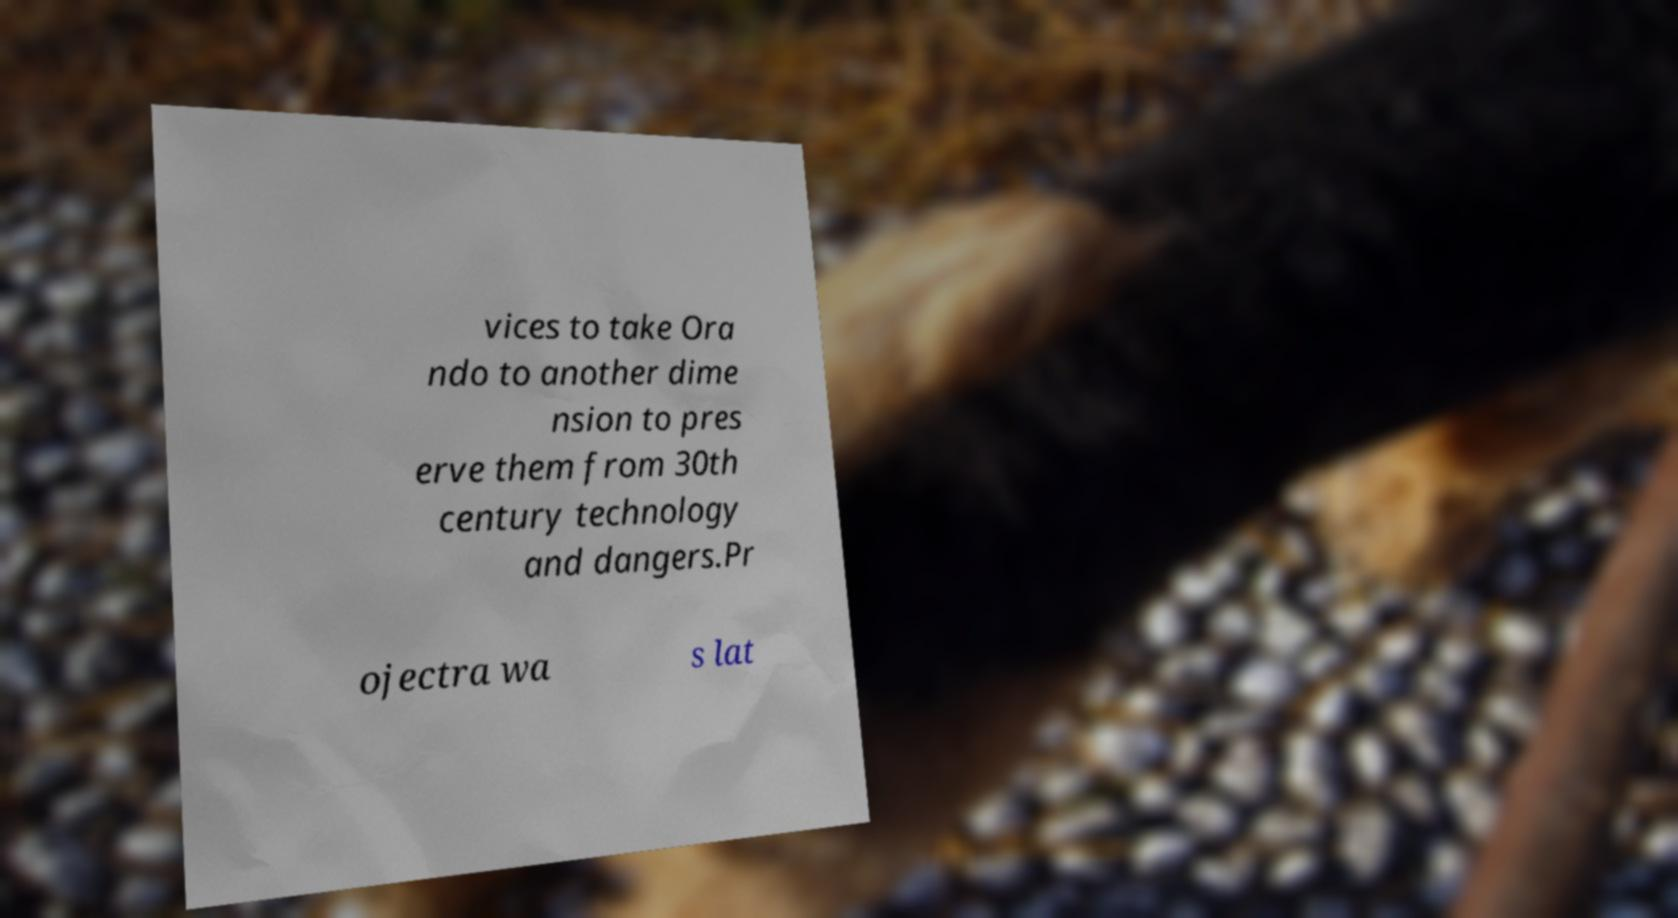Could you assist in decoding the text presented in this image and type it out clearly? vices to take Ora ndo to another dime nsion to pres erve them from 30th century technology and dangers.Pr ojectra wa s lat 